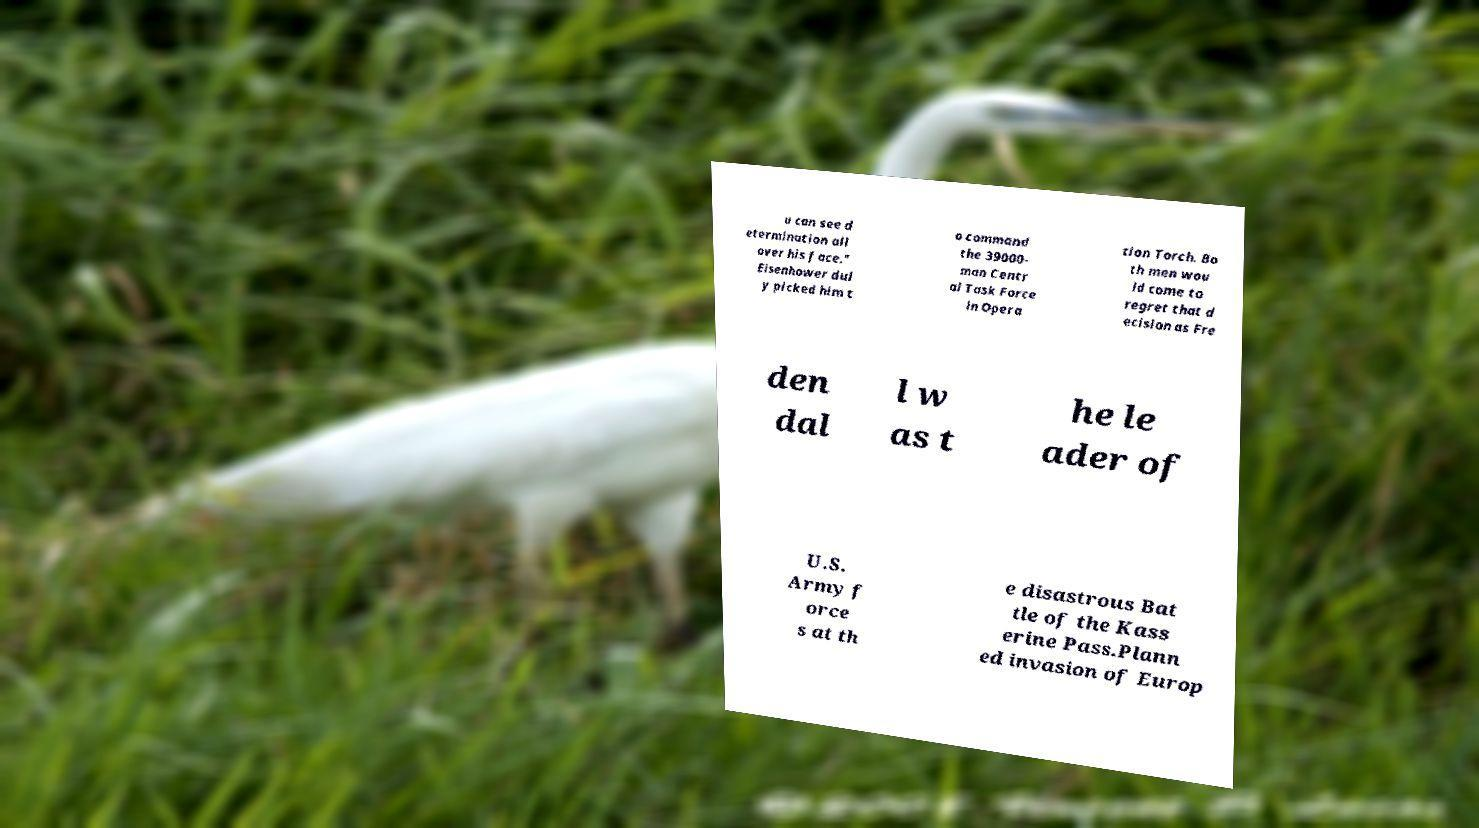Can you accurately transcribe the text from the provided image for me? u can see d etermination all over his face." Eisenhower dul y picked him t o command the 39000- man Centr al Task Force in Opera tion Torch. Bo th men wou ld come to regret that d ecision as Fre den dal l w as t he le ader of U.S. Army f orce s at th e disastrous Bat tle of the Kass erine Pass.Plann ed invasion of Europ 